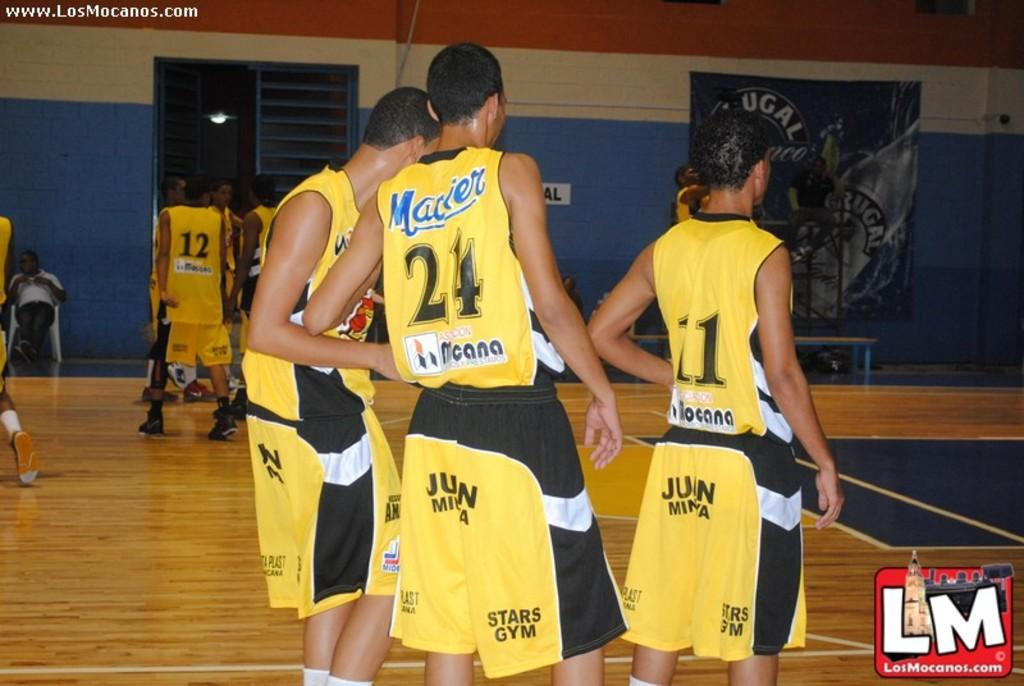<image>
Render a clear and concise summary of the photo. Stars Gym is printed on the yellow shorts of the players. 